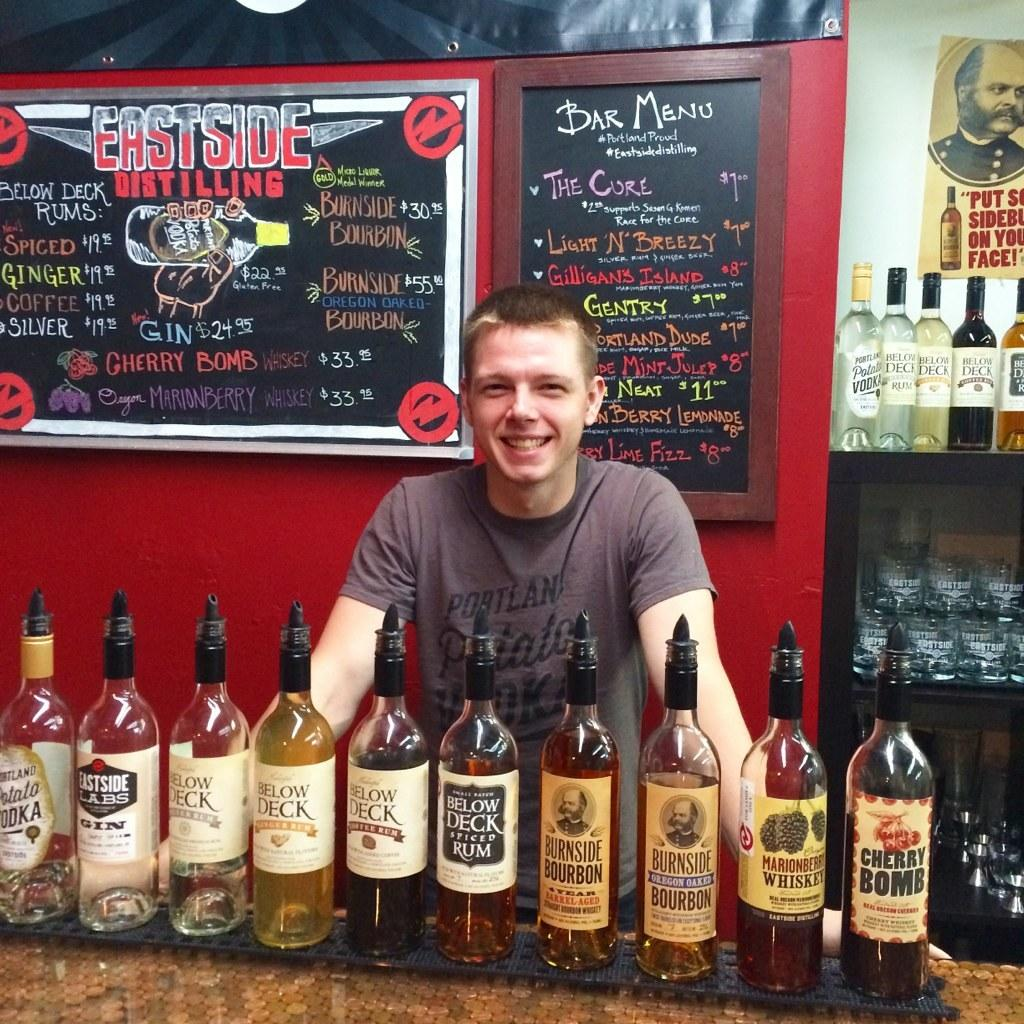Who is present in the image? There is a man in the image. What is in front of the man? There are wine bottles in front of the man. What type of stew is being prepared in the image? There is no stew present in the image; it only features a man and wine bottles. 